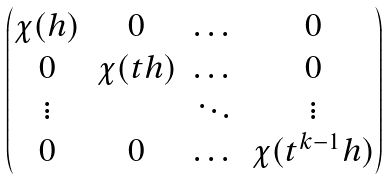Convert formula to latex. <formula><loc_0><loc_0><loc_500><loc_500>\begin{pmatrix} \chi ( h ) & 0 & \dots & 0 \\ 0 & \chi ( t h ) & \dots & 0 \\ \vdots & & \ddots & \vdots \\ 0 & 0 & \dots & \chi ( t ^ { k - 1 } h ) \end{pmatrix}</formula> 